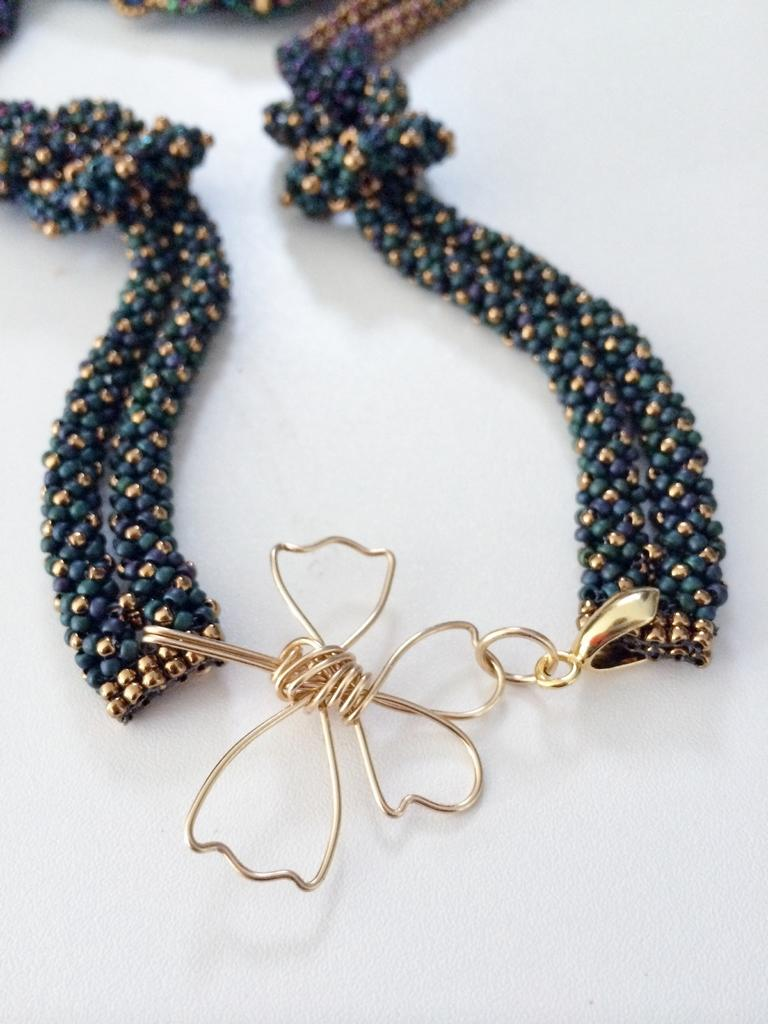What type of object is in the image? There is an accessory in the image. What colors are present on the accessory? The accessory has blue and gold colors. What is the color of the surface on which the accessory is placed? The accessory is on a white color surface. What type of border is visible around the accessory in the image? There is no border visible around the accessory in the image. What type of hose is connected to the accessory in the image? There is no hose connected to the accessory in the image. 